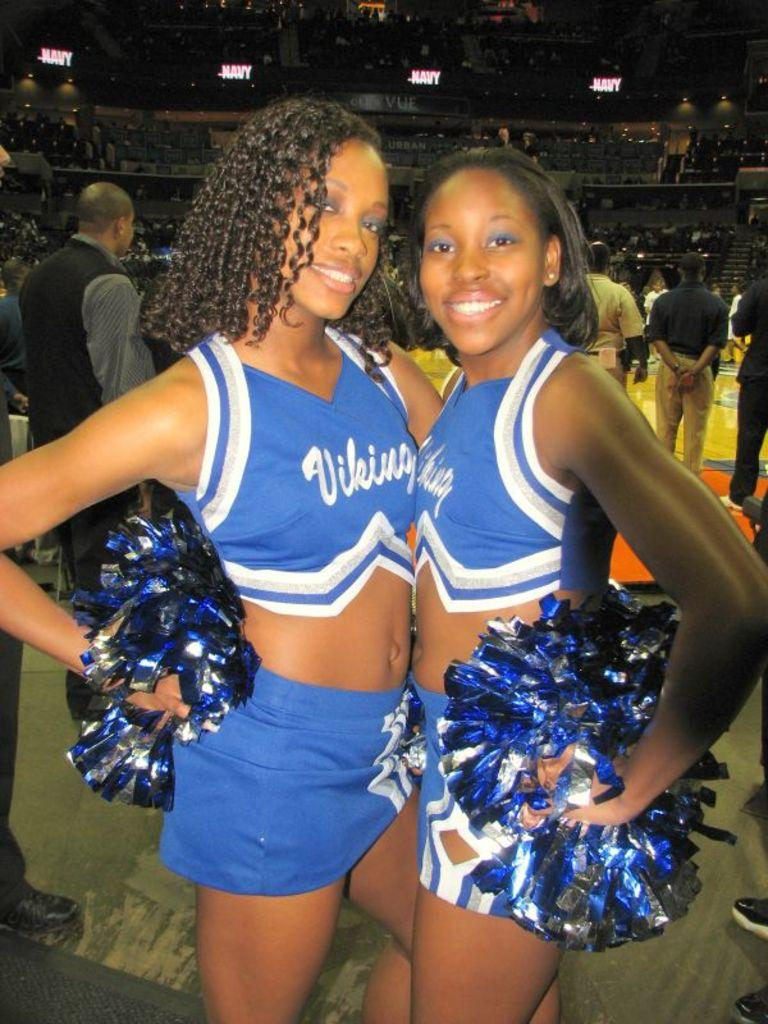<image>
Relay a brief, clear account of the picture shown. Two Vikings cheerleaders wearing blue and white hold their pom poms as they pose for a photo whilst the game goes on behind them. 